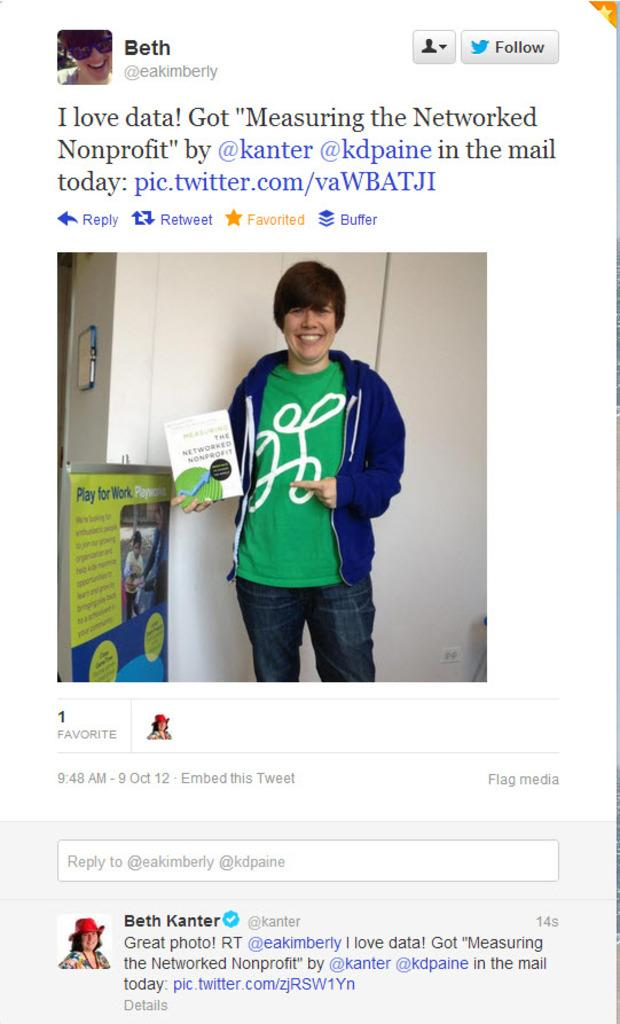<image>
Provide a brief description of the given image. A woman named Beth is posing for a photo on a tweet for a book. 